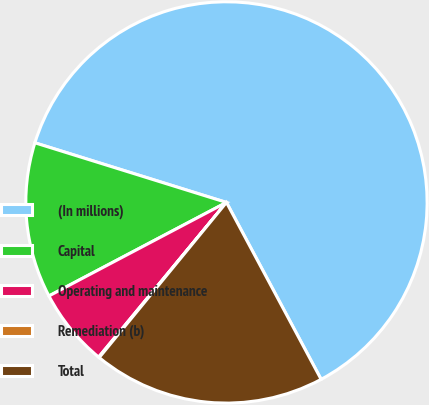<chart> <loc_0><loc_0><loc_500><loc_500><pie_chart><fcel>(In millions)<fcel>Capital<fcel>Operating and maintenance<fcel>Remediation (b)<fcel>Total<nl><fcel>62.37%<fcel>12.52%<fcel>6.29%<fcel>0.06%<fcel>18.75%<nl></chart> 